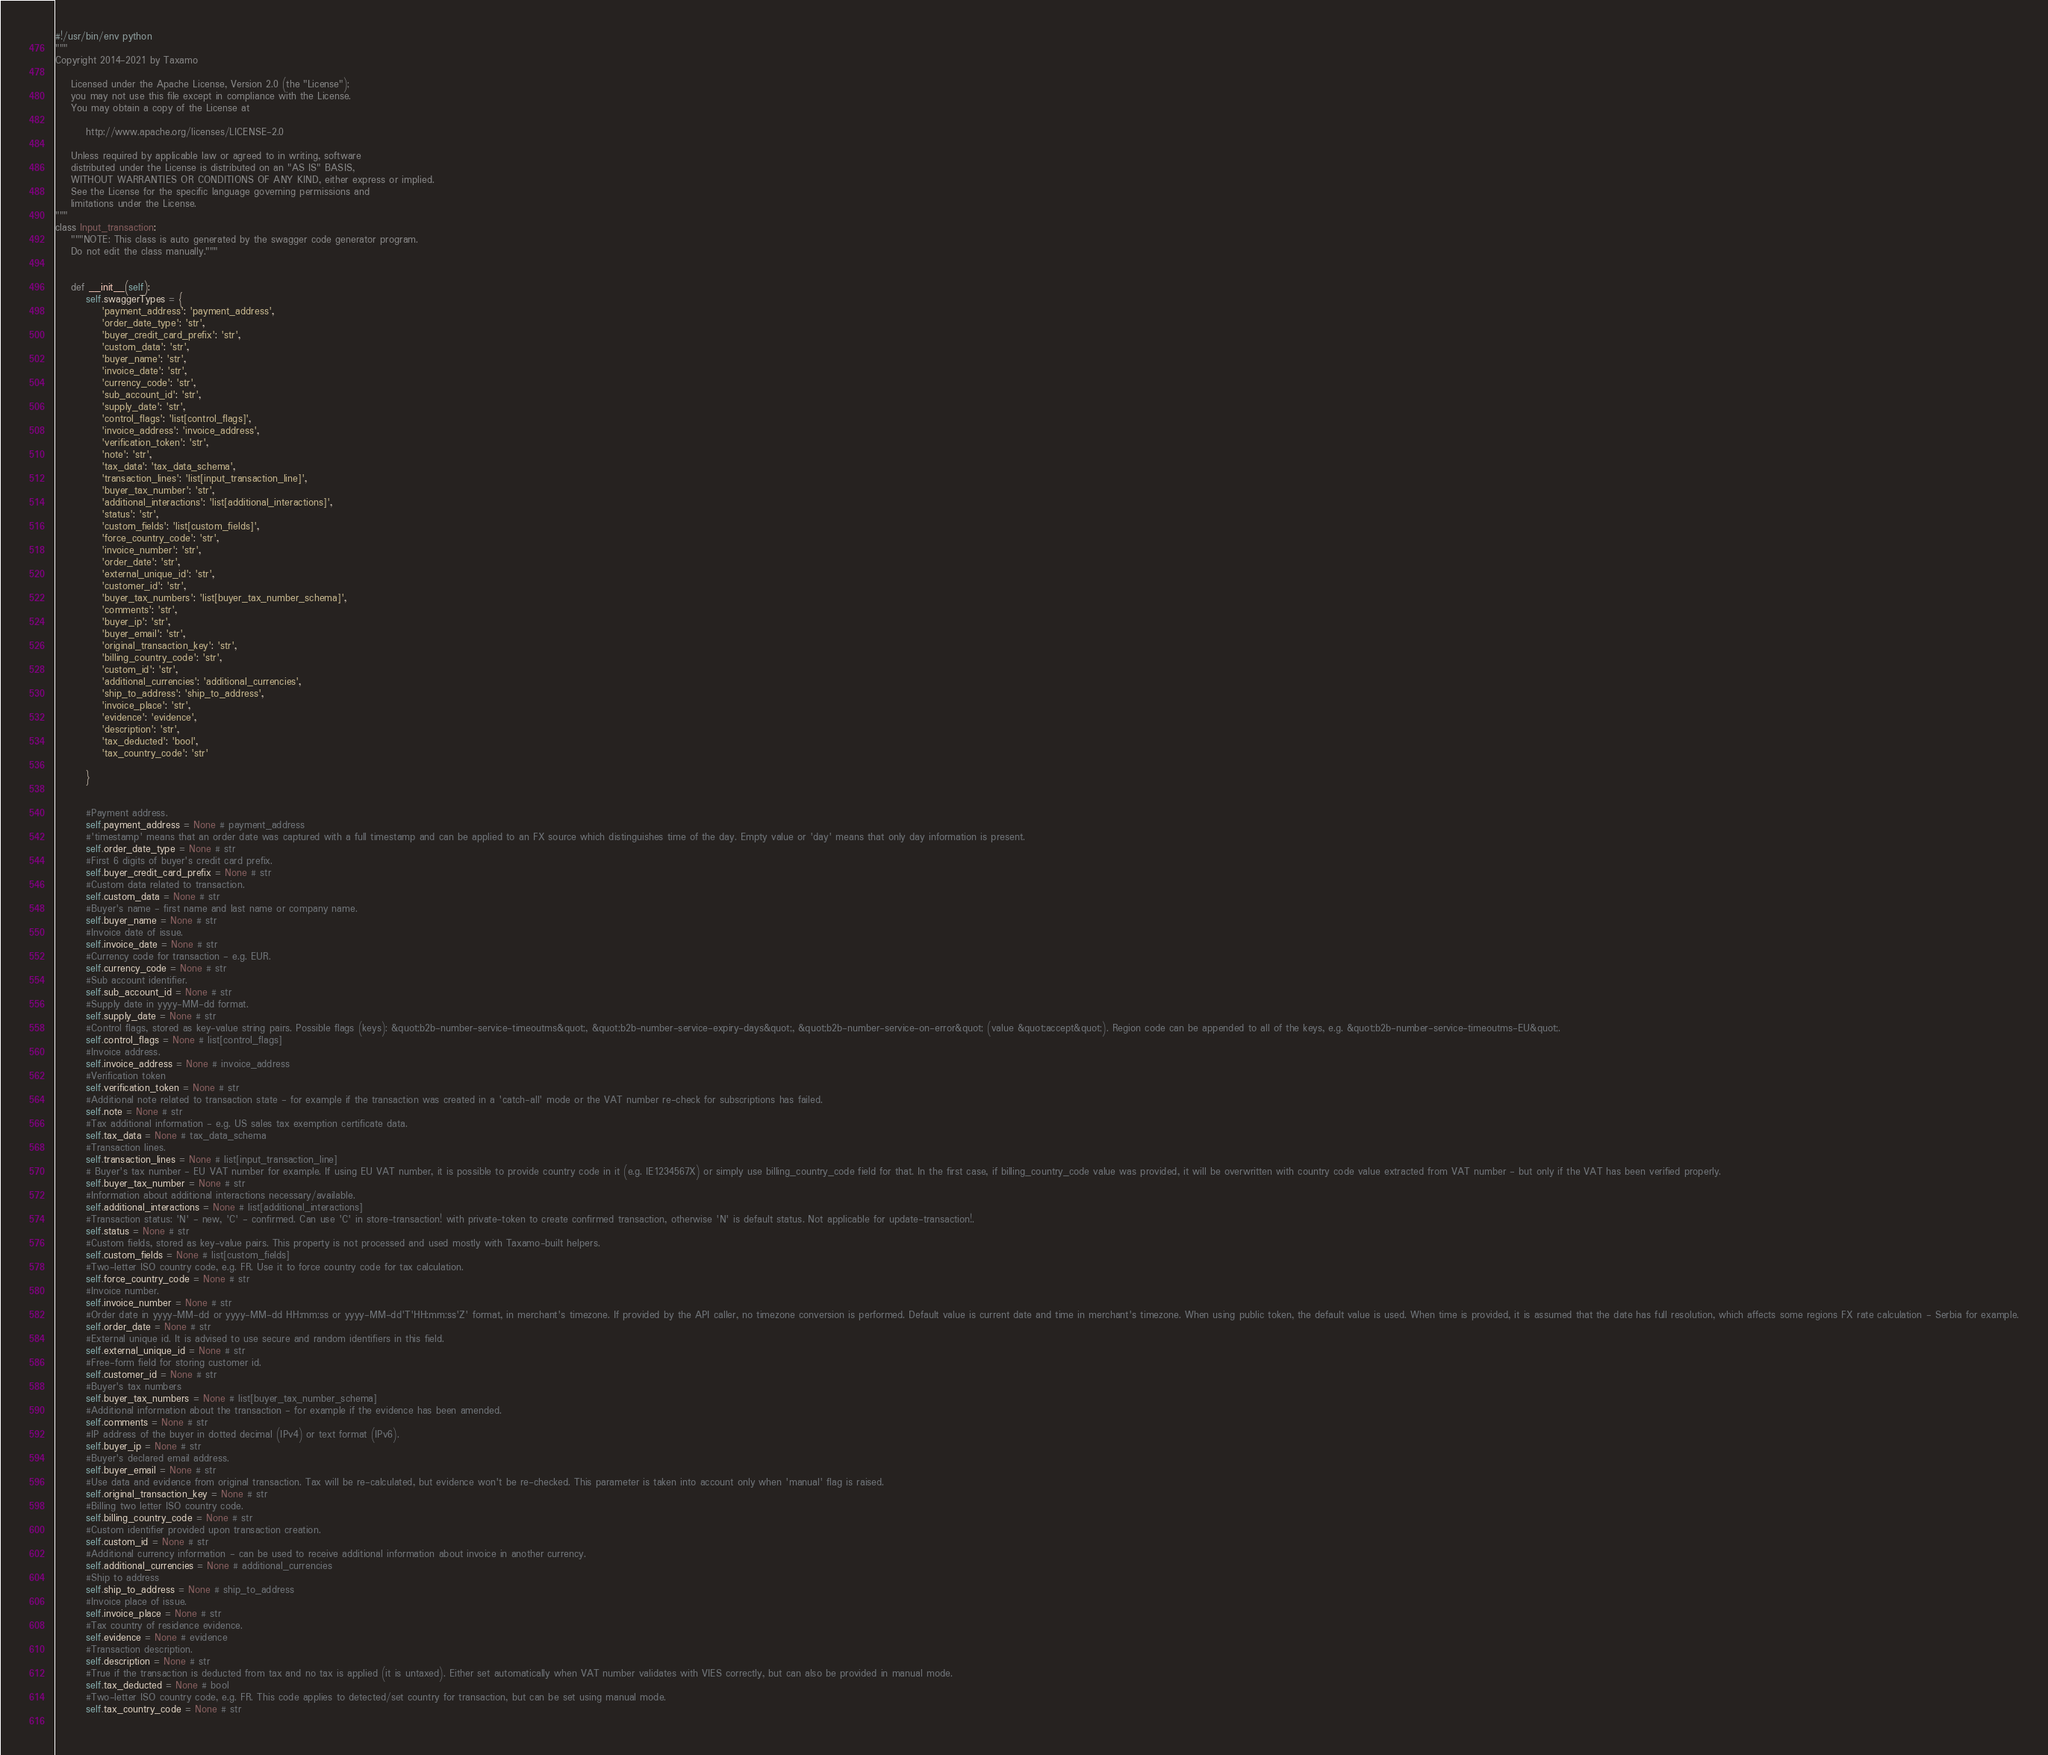<code> <loc_0><loc_0><loc_500><loc_500><_Python_>#!/usr/bin/env python
"""
Copyright 2014-2021 by Taxamo

    Licensed under the Apache License, Version 2.0 (the "License");
    you may not use this file except in compliance with the License.
    You may obtain a copy of the License at

        http://www.apache.org/licenses/LICENSE-2.0

    Unless required by applicable law or agreed to in writing, software
    distributed under the License is distributed on an "AS IS" BASIS,
    WITHOUT WARRANTIES OR CONDITIONS OF ANY KIND, either express or implied.
    See the License for the specific language governing permissions and
    limitations under the License.
"""
class Input_transaction:
    """NOTE: This class is auto generated by the swagger code generator program.
    Do not edit the class manually."""


    def __init__(self):
        self.swaggerTypes = {
            'payment_address': 'payment_address',
            'order_date_type': 'str',
            'buyer_credit_card_prefix': 'str',
            'custom_data': 'str',
            'buyer_name': 'str',
            'invoice_date': 'str',
            'currency_code': 'str',
            'sub_account_id': 'str',
            'supply_date': 'str',
            'control_flags': 'list[control_flags]',
            'invoice_address': 'invoice_address',
            'verification_token': 'str',
            'note': 'str',
            'tax_data': 'tax_data_schema',
            'transaction_lines': 'list[input_transaction_line]',
            'buyer_tax_number': 'str',
            'additional_interactions': 'list[additional_interactions]',
            'status': 'str',
            'custom_fields': 'list[custom_fields]',
            'force_country_code': 'str',
            'invoice_number': 'str',
            'order_date': 'str',
            'external_unique_id': 'str',
            'customer_id': 'str',
            'buyer_tax_numbers': 'list[buyer_tax_number_schema]',
            'comments': 'str',
            'buyer_ip': 'str',
            'buyer_email': 'str',
            'original_transaction_key': 'str',
            'billing_country_code': 'str',
            'custom_id': 'str',
            'additional_currencies': 'additional_currencies',
            'ship_to_address': 'ship_to_address',
            'invoice_place': 'str',
            'evidence': 'evidence',
            'description': 'str',
            'tax_deducted': 'bool',
            'tax_country_code': 'str'

        }


        #Payment address.
        self.payment_address = None # payment_address
        #'timestamp' means that an order date was captured with a full timestamp and can be applied to an FX source which distinguishes time of the day. Empty value or 'day' means that only day information is present.
        self.order_date_type = None # str
        #First 6 digits of buyer's credit card prefix.
        self.buyer_credit_card_prefix = None # str
        #Custom data related to transaction.
        self.custom_data = None # str
        #Buyer's name - first name and last name or company name.
        self.buyer_name = None # str
        #Invoice date of issue.
        self.invoice_date = None # str
        #Currency code for transaction - e.g. EUR.
        self.currency_code = None # str
        #Sub account identifier.
        self.sub_account_id = None # str
        #Supply date in yyyy-MM-dd format.
        self.supply_date = None # str
        #Control flags, stored as key-value string pairs. Possible flags (keys): &quot;b2b-number-service-timeoutms&quot;, &quot;b2b-number-service-expiry-days&quot;, &quot;b2b-number-service-on-error&quot; (value &quot;accept&quot;). Region code can be appended to all of the keys, e.g. &quot;b2b-number-service-timeoutms-EU&quot;. 
        self.control_flags = None # list[control_flags]
        #Invoice address.
        self.invoice_address = None # invoice_address
        #Verification token
        self.verification_token = None # str
        #Additional note related to transaction state - for example if the transaction was created in a 'catch-all' mode or the VAT number re-check for subscriptions has failed.
        self.note = None # str
        #Tax additional information - e.g. US sales tax exemption certificate data.
        self.tax_data = None # tax_data_schema
        #Transaction lines.
        self.transaction_lines = None # list[input_transaction_line]
        # Buyer's tax number - EU VAT number for example. If using EU VAT number, it is possible to provide country code in it (e.g. IE1234567X) or simply use billing_country_code field for that. In the first case, if billing_country_code value was provided, it will be overwritten with country code value extracted from VAT number - but only if the VAT has been verified properly.
        self.buyer_tax_number = None # str
        #Information about additional interactions necessary/available.
        self.additional_interactions = None # list[additional_interactions]
        #Transaction status: 'N' - new, 'C' - confirmed. Can use 'C' in store-transaction! with private-token to create confirmed transaction, otherwise 'N' is default status. Not applicable for update-transaction!.
        self.status = None # str
        #Custom fields, stored as key-value pairs. This property is not processed and used mostly with Taxamo-built helpers.
        self.custom_fields = None # list[custom_fields]
        #Two-letter ISO country code, e.g. FR. Use it to force country code for tax calculation.
        self.force_country_code = None # str
        #Invoice number.
        self.invoice_number = None # str
        #Order date in yyyy-MM-dd or yyyy-MM-dd HH:mm:ss or yyyy-MM-dd'T'HH:mm:ss'Z' format, in merchant's timezone. If provided by the API caller, no timezone conversion is performed. Default value is current date and time in merchant's timezone. When using public token, the default value is used. When time is provided, it is assumed that the date has full resolution, which affects some regions FX rate calculation - Serbia for example.
        self.order_date = None # str
        #External unique id. It is advised to use secure and random identifiers in this field.
        self.external_unique_id = None # str
        #Free-form field for storing customer id.
        self.customer_id = None # str
        #Buyer's tax numbers
        self.buyer_tax_numbers = None # list[buyer_tax_number_schema]
        #Additional information about the transaction - for example if the evidence has been amended.
        self.comments = None # str
        #IP address of the buyer in dotted decimal (IPv4) or text format (IPv6).
        self.buyer_ip = None # str
        #Buyer's declared email address.
        self.buyer_email = None # str
        #Use data and evidence from original transaction. Tax will be re-calculated, but evidence won't be re-checked. This parameter is taken into account only when 'manual' flag is raised.
        self.original_transaction_key = None # str
        #Billing two letter ISO country code.
        self.billing_country_code = None # str
        #Custom identifier provided upon transaction creation.
        self.custom_id = None # str
        #Additional currency information - can be used to receive additional information about invoice in another currency.
        self.additional_currencies = None # additional_currencies
        #Ship to address
        self.ship_to_address = None # ship_to_address
        #Invoice place of issue.
        self.invoice_place = None # str
        #Tax country of residence evidence.
        self.evidence = None # evidence
        #Transaction description.
        self.description = None # str
        #True if the transaction is deducted from tax and no tax is applied (it is untaxed). Either set automatically when VAT number validates with VIES correctly, but can also be provided in manual mode.
        self.tax_deducted = None # bool
        #Two-letter ISO country code, e.g. FR. This code applies to detected/set country for transaction, but can be set using manual mode.
        self.tax_country_code = None # str
        
</code> 